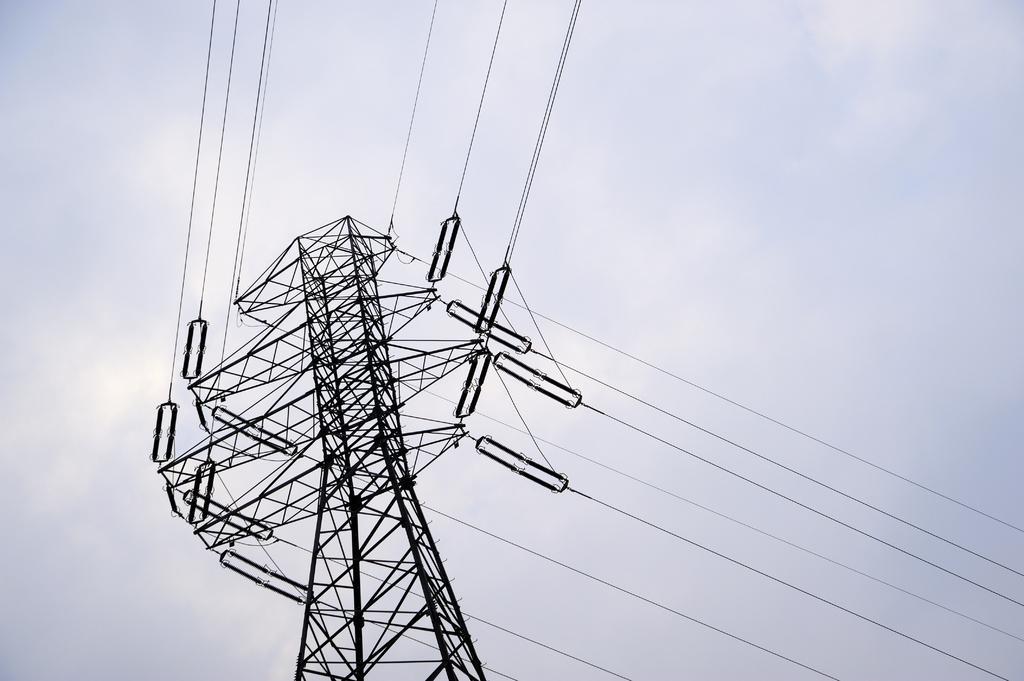How would you summarize this image in a sentence or two? This picture is of outside. In the center there is a transmission pole to which many number of cables are attached and we can see the sky. 